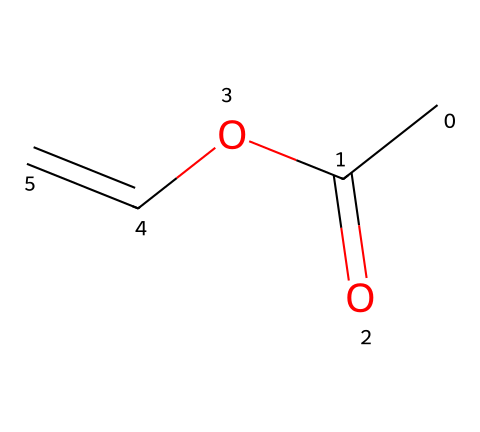What is the molecular formula of this compound? To determine the molecular formula, we need to count the number of each type of atom represented in the SMILES notation. The molecular formula can be derived from CC(=O)OC=C, which indicates the presence of 4 carbon atoms (C), 6 hydrogen atoms (H), and 2 oxygen atoms (O). Therefore, the molecular formula is C4H6O2.
Answer: C4H6O2 How many double bonds are present in the structure? The SMILES notation CC(=O)OC=C shows two locations where double bonds are indicated: one in the carbonyl group (=O) and one between the last two carbon atoms (C=C). Counting these gives a total of 2 double bonds.
Answer: 2 What type of functional groups are present? Analyzing the structure reveals two types of functional groups: the ester functional group (C(=O)O) and the alkene functional group (C=C). These groups can be identified from the positioning and types of bonds within the SMILES notation.
Answer: ester, alkene Is this compound a monomer? A monomer is a small molecular unit that can join together to form polymers. Given that this compound is structured to have reactive double bonds (C=C) and can link with other similar units, it qualifies as a monomer suitable for polymerization.
Answer: yes What is the main use of this type of chemical in adhesives? The presence of reactive functional groups such as the alkene and ester makes this monomer useful in adhesive formulations. It can polymerize to create strong bonds and flexible structures, which are essential properties for an adhesive used in art framing.
Answer: adhesion 